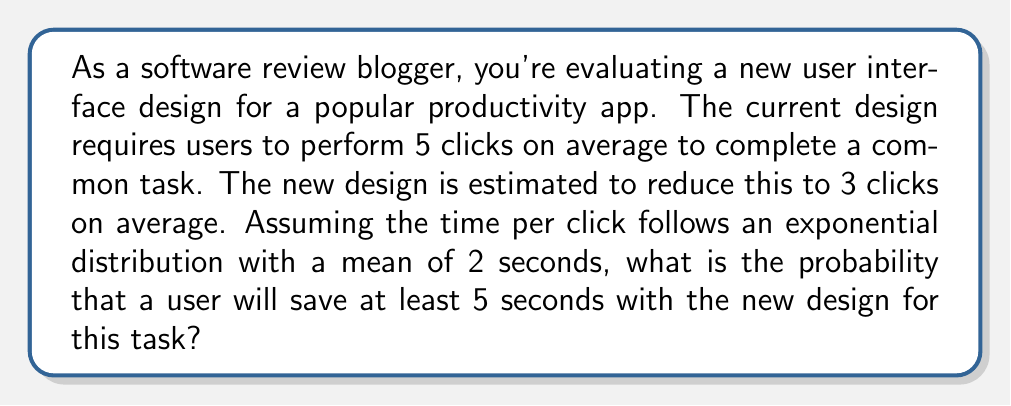Can you answer this question? Let's approach this step-by-step:

1) First, we need to calculate the difference in the number of clicks:
   $5 - 3 = 2$ clicks saved

2) The time saved is the sum of two exponentially distributed random variables (since we're saving 2 clicks).

3) The sum of $n$ independent exponential random variables, each with rate $\lambda$, follows a Gamma distribution with shape parameter $n$ and rate $\lambda$.

4) In this case, $n = 2$ (two clicks saved) and $\lambda = \frac{1}{\text{mean}} = \frac{1}{2} = 0.5$ (since the mean time per click is 2 seconds).

5) We want to find $P(X \geq 5)$, where $X$ is the time saved.

6) This is equivalent to $1 - P(X < 5)$.

7) The cumulative distribution function (CDF) of a Gamma distribution is given by the lower incomplete gamma function:

   $P(X < x) = \frac{\gamma(n, \lambda x)}{\Gamma(n)}$

   Where $\gamma(n, x)$ is the lower incomplete gamma function and $\Gamma(n)$ is the gamma function.

8) In our case:

   $P(X < 5) = \frac{\gamma(2, 0.5 * 5)}{\Gamma(2)}$

9) This can be calculated using statistical software or mathematical libraries. The result is approximately 0.7769.

10) Therefore, $P(X \geq 5) = 1 - 0.7769 \approx 0.2231$
Answer: The probability that a user will save at least 5 seconds with the new design is approximately 0.2231 or 22.31%. 